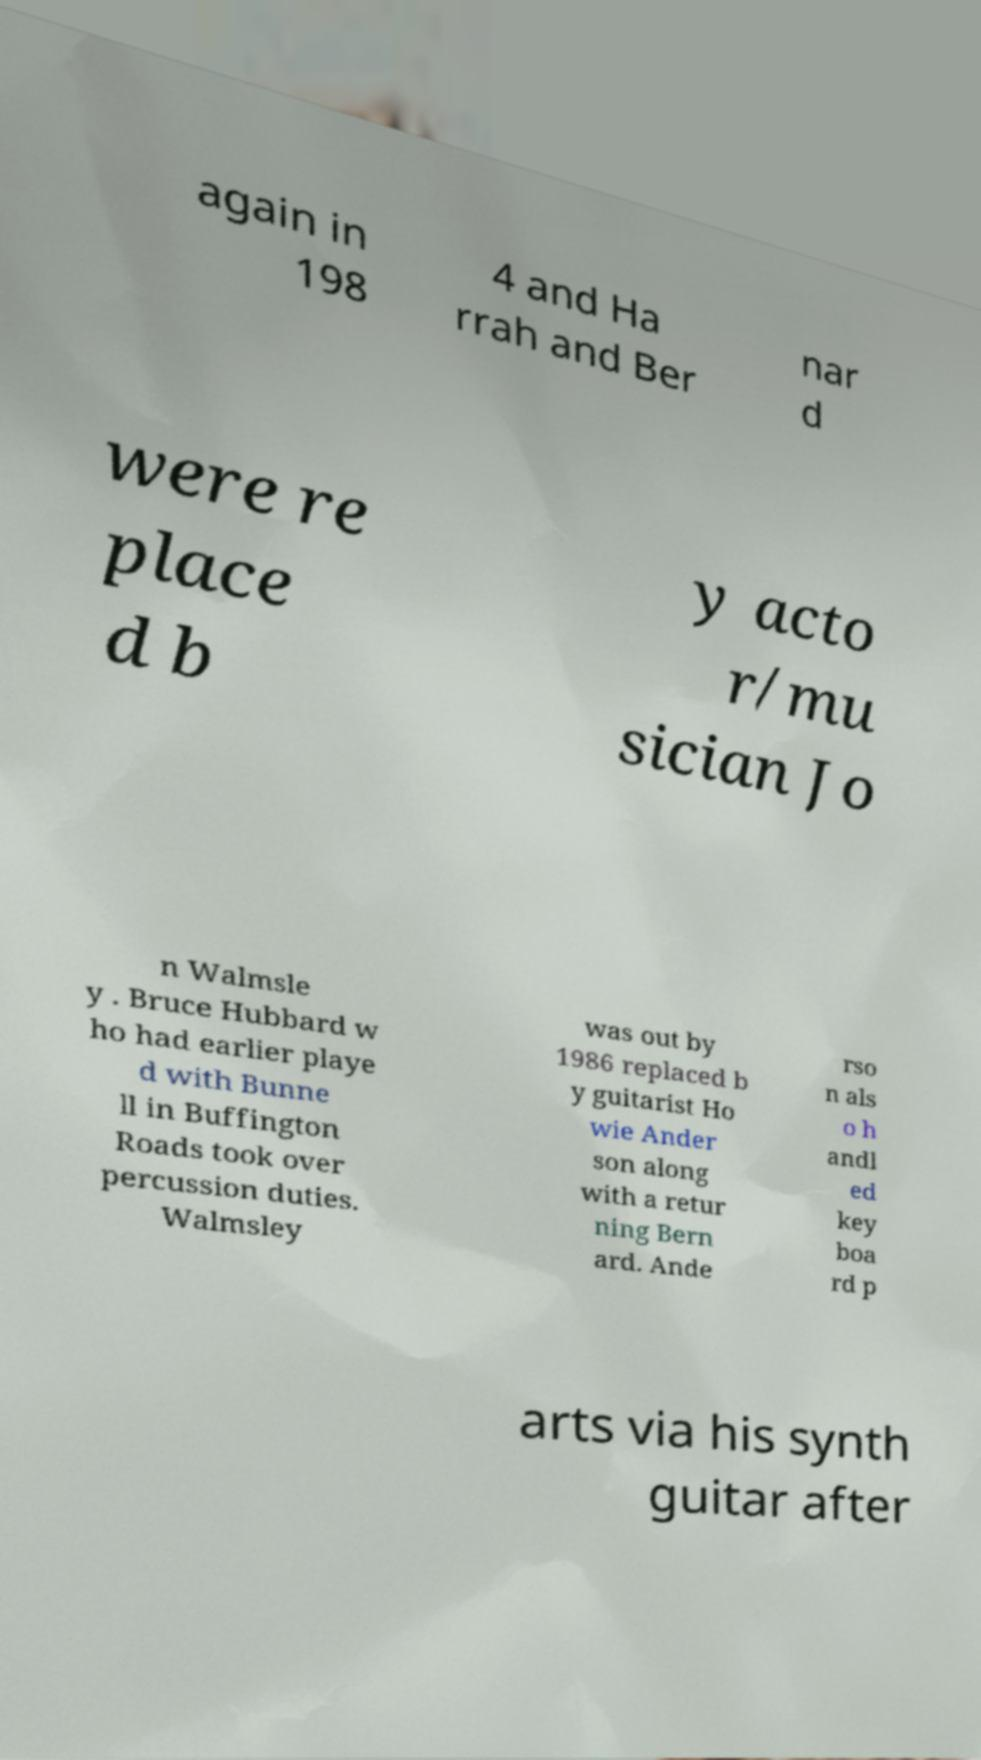Please identify and transcribe the text found in this image. again in 198 4 and Ha rrah and Ber nar d were re place d b y acto r/mu sician Jo n Walmsle y . Bruce Hubbard w ho had earlier playe d with Bunne ll in Buffington Roads took over percussion duties. Walmsley was out by 1986 replaced b y guitarist Ho wie Ander son along with a retur ning Bern ard. Ande rso n als o h andl ed key boa rd p arts via his synth guitar after 